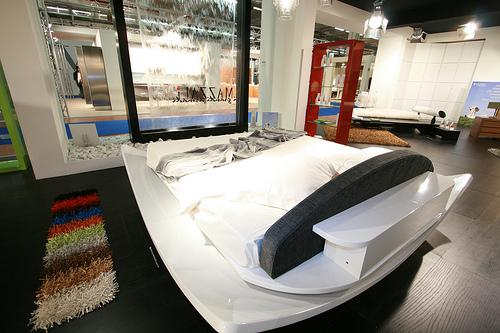Question: how is the weather?
Choices:
A. Sunny.
B. Cloudy.
C. Rainy.
D. Cold.
Answer with the letter. Answer: A Question: where are the lights?
Choices:
A. Outside.
B. A wall.
C. On the floor.
D. The ceiling.
Answer with the letter. Answer: D Question: what color is the rug?
Choices:
A. Black.
B. White.
C. Multi colored.
D. Brown.
Answer with the letter. Answer: C 